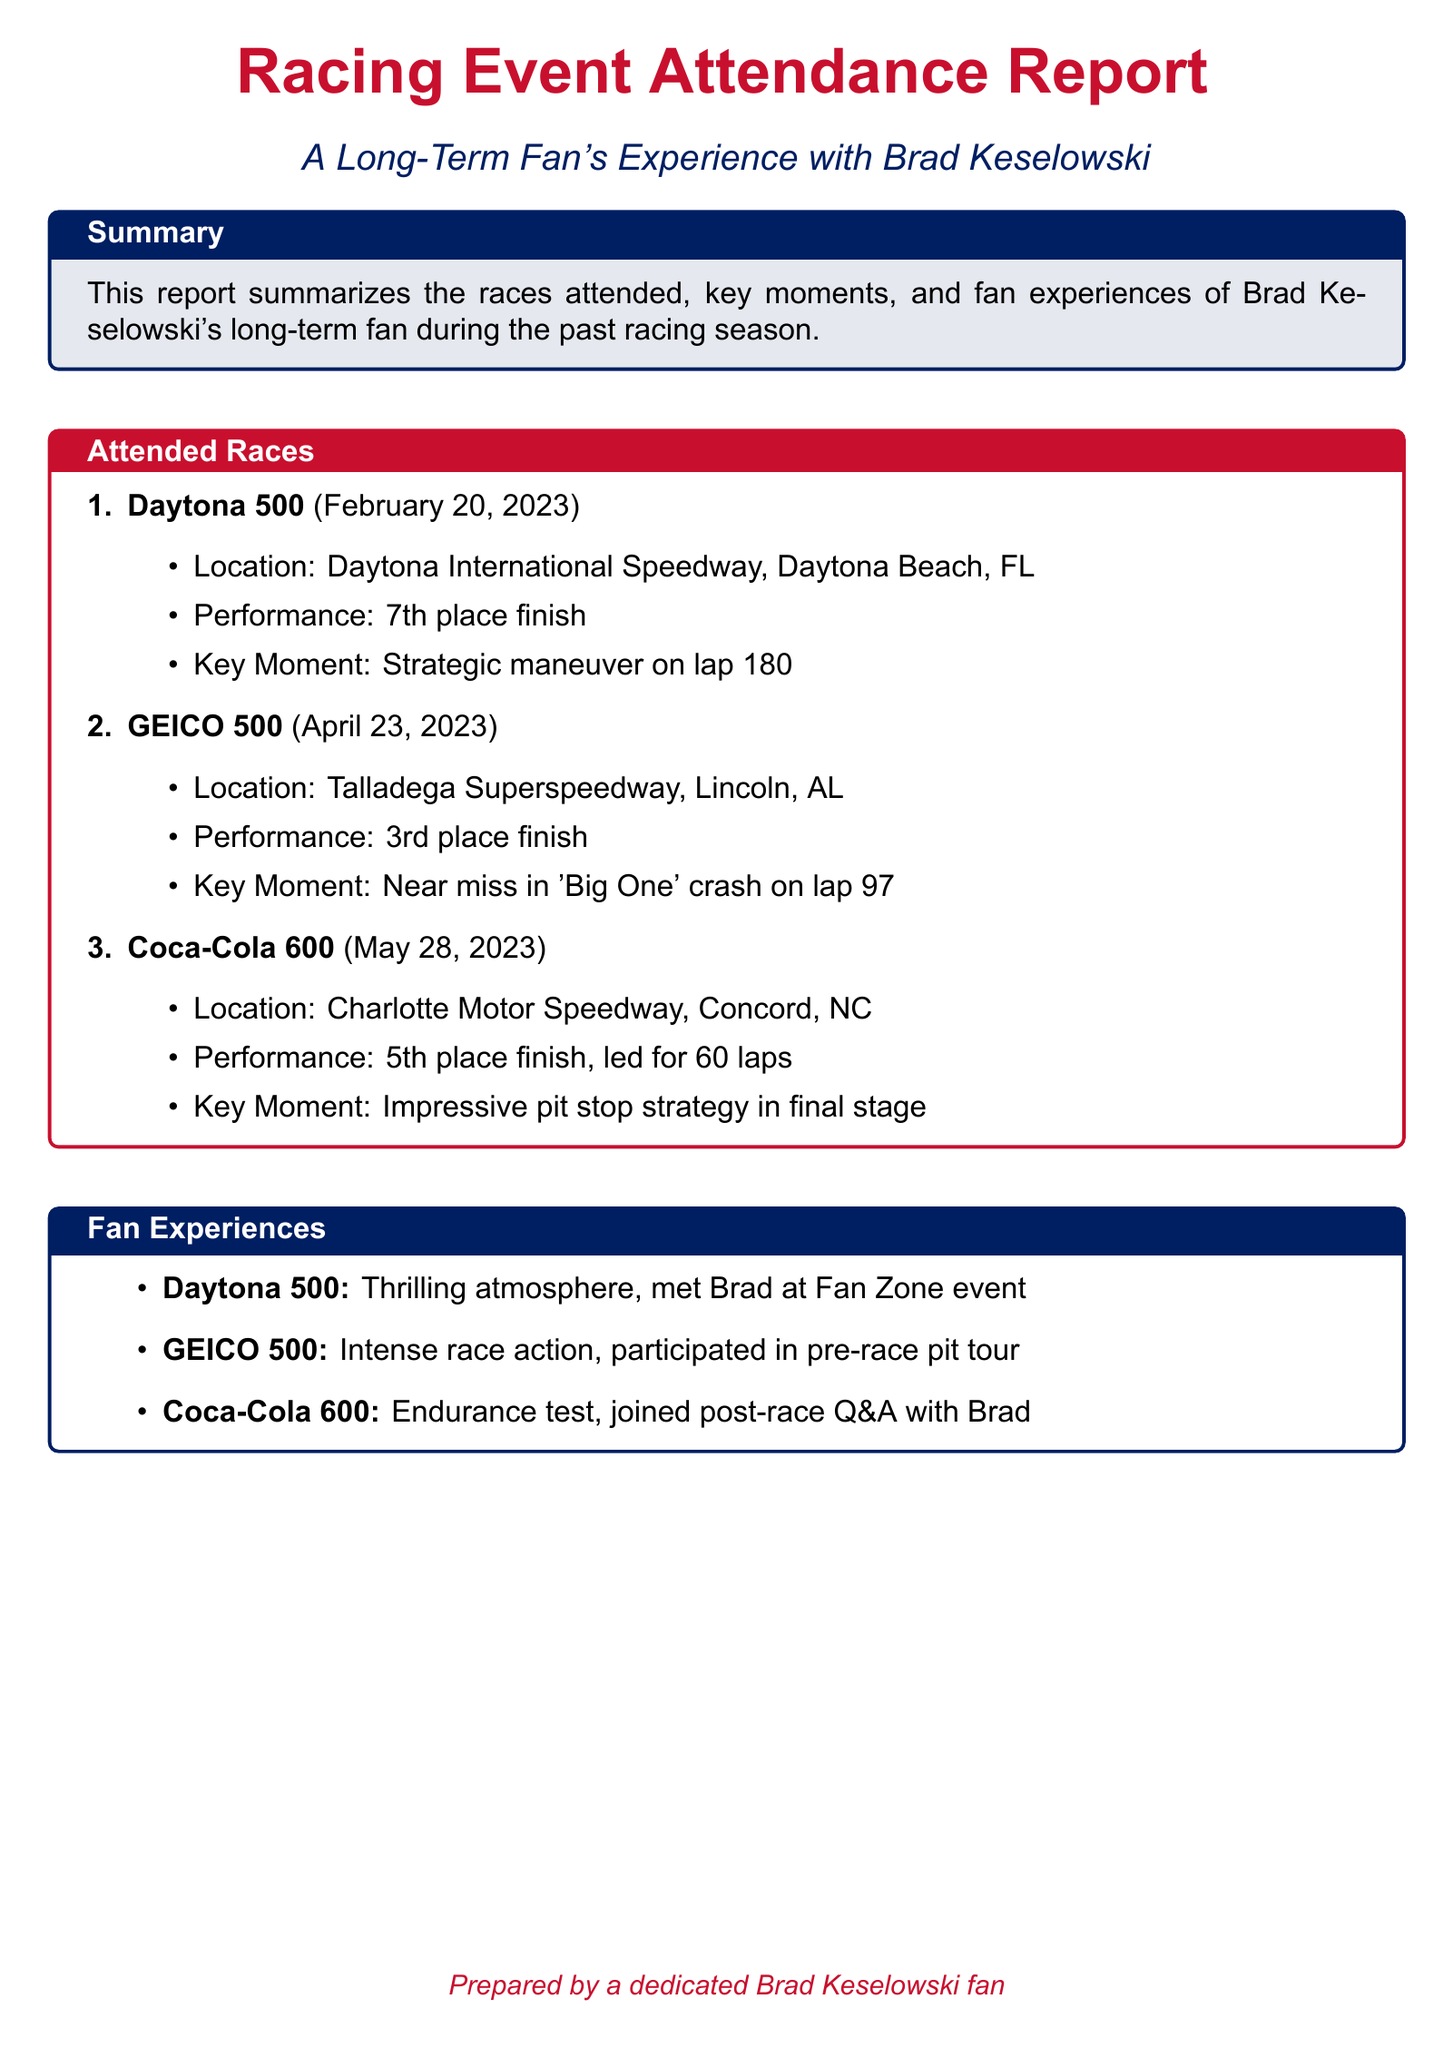What was Brad Keselowski's finish in the Daytona 500? The document states that Brad finished in 7th place during the Daytona 500.
Answer: 7th place What was the key moment in the GEICO 500? The document highlights that the key moment was a near miss in the 'Big One' crash on lap 97.
Answer: Near miss in 'Big One' crash How many laps did Brad lead in the Coca-Cola 600? According to the document, Brad led for 60 laps during the Coca-Cola 600.
Answer: 60 laps What fan experience occurred during the Daytona 500? The document notes that the fan experienced a thrilling atmosphere and met Brad at a Fan Zone event at the Daytona 500.
Answer: Met Brad at Fan Zone event Which race had an impressive pit stop strategy? The document states that the Coca-Cola 600 featured an impressive pit stop strategy in the final stage.
Answer: Coca-Cola 600 What was the performance of Brad in the GEICO 500? The document indicates that Brad finished in 3rd place in the GEICO 500.
Answer: 3rd place Where did the Coca-Cola 600 take place? The document mentions that the Coca-Cola 600 took place at Charlotte Motor Speedway in Concord, NC.
Answer: Charlotte Motor Speedway What was the date of the Daytona 500? The document specifies that the Daytona 500 occurred on February 20, 2023.
Answer: February 20, 2023 